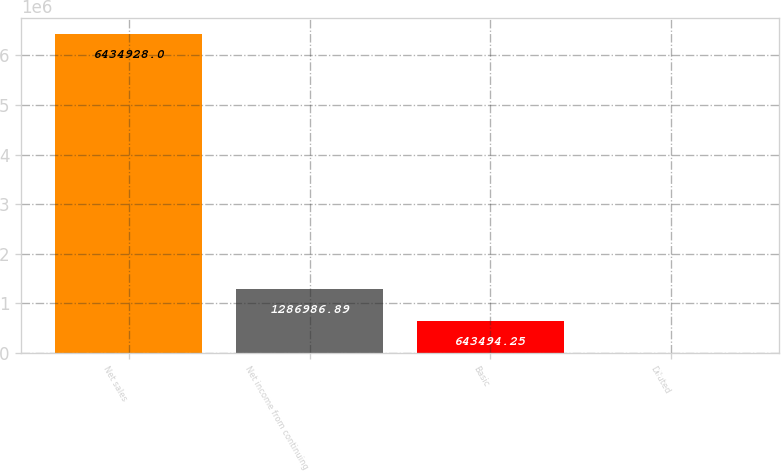<chart> <loc_0><loc_0><loc_500><loc_500><bar_chart><fcel>Net sales<fcel>Net income from continuing<fcel>Basic<fcel>Diluted<nl><fcel>6.43493e+06<fcel>1.28699e+06<fcel>643494<fcel>1.61<nl></chart> 